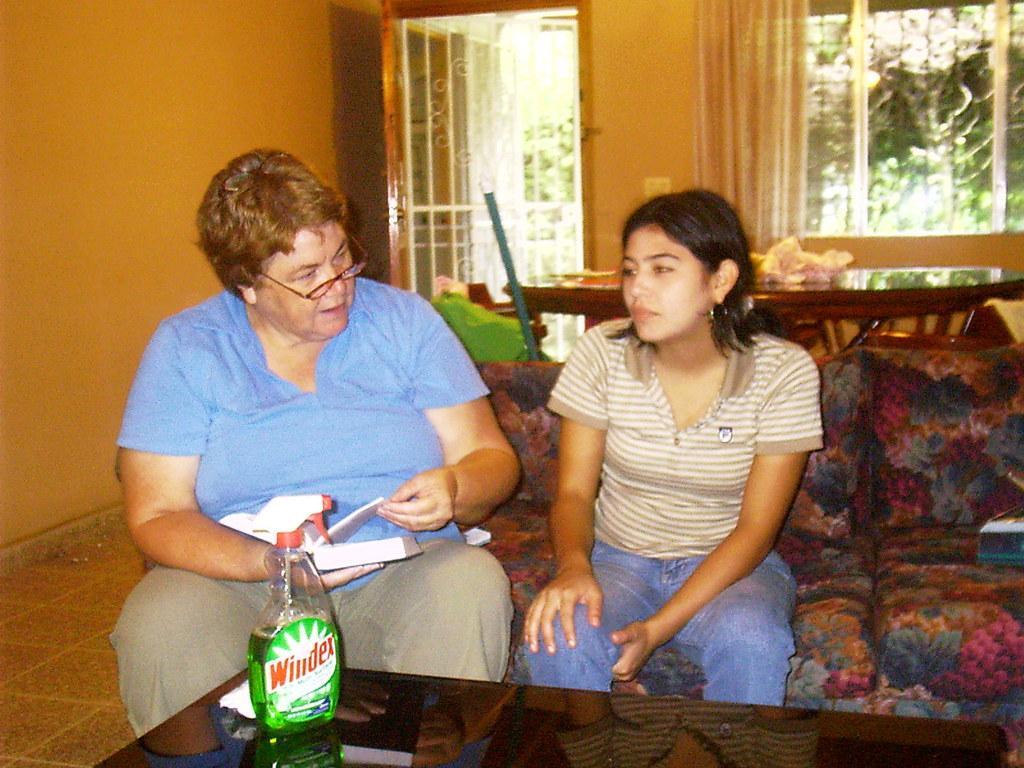Describe this image in one or two sentences. As we can see in the image there is a orange color wall, window and two people sitting on sofa. In front of them there is a table. On table there is a bottle. 